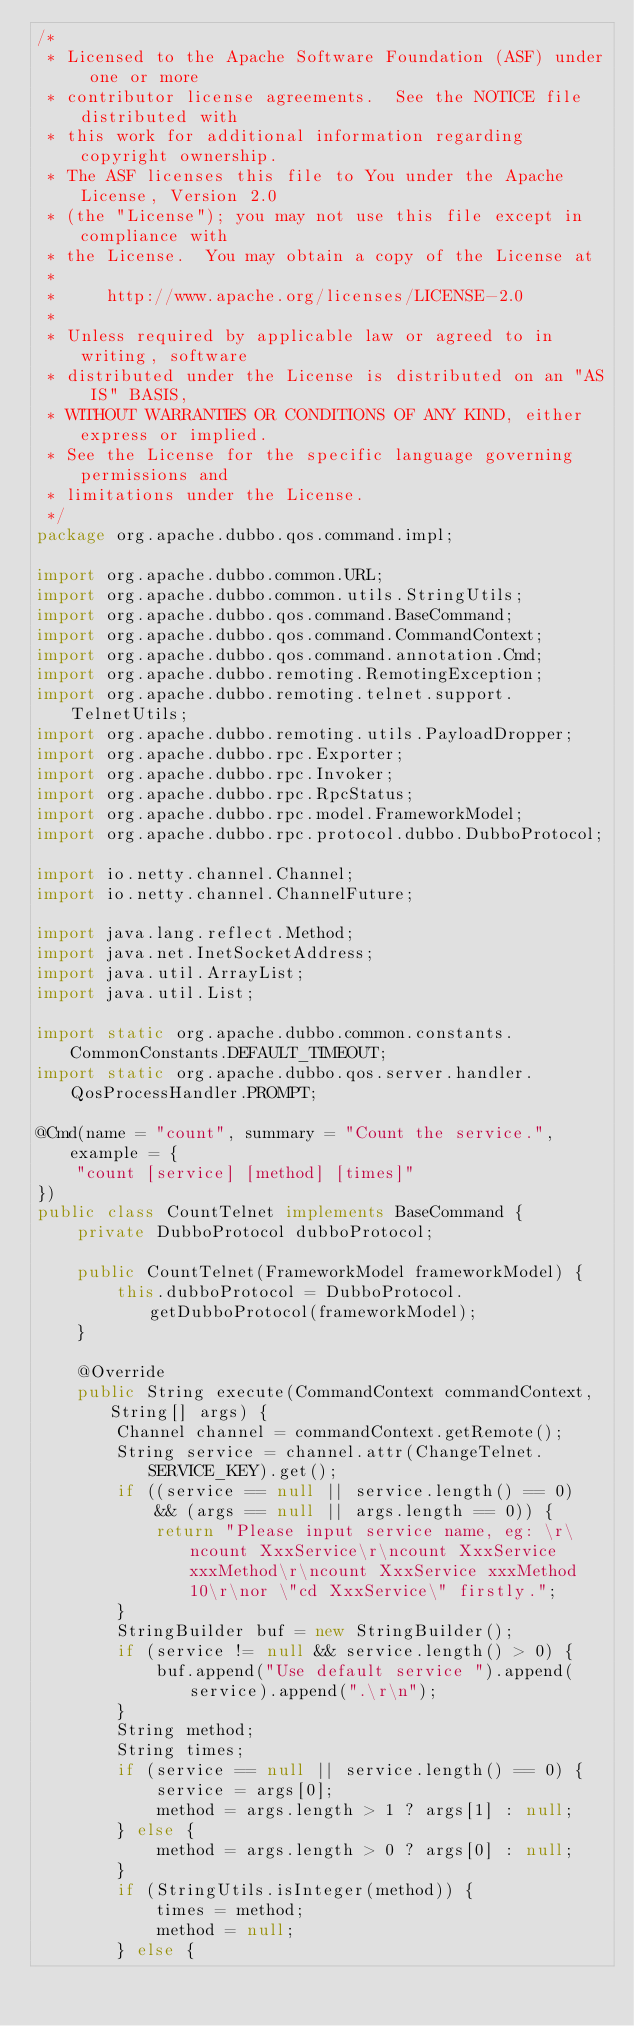Convert code to text. <code><loc_0><loc_0><loc_500><loc_500><_Java_>/*
 * Licensed to the Apache Software Foundation (ASF) under one or more
 * contributor license agreements.  See the NOTICE file distributed with
 * this work for additional information regarding copyright ownership.
 * The ASF licenses this file to You under the Apache License, Version 2.0
 * (the "License"); you may not use this file except in compliance with
 * the License.  You may obtain a copy of the License at
 *
 *     http://www.apache.org/licenses/LICENSE-2.0
 *
 * Unless required by applicable law or agreed to in writing, software
 * distributed under the License is distributed on an "AS IS" BASIS,
 * WITHOUT WARRANTIES OR CONDITIONS OF ANY KIND, either express or implied.
 * See the License for the specific language governing permissions and
 * limitations under the License.
 */
package org.apache.dubbo.qos.command.impl;

import org.apache.dubbo.common.URL;
import org.apache.dubbo.common.utils.StringUtils;
import org.apache.dubbo.qos.command.BaseCommand;
import org.apache.dubbo.qos.command.CommandContext;
import org.apache.dubbo.qos.command.annotation.Cmd;
import org.apache.dubbo.remoting.RemotingException;
import org.apache.dubbo.remoting.telnet.support.TelnetUtils;
import org.apache.dubbo.remoting.utils.PayloadDropper;
import org.apache.dubbo.rpc.Exporter;
import org.apache.dubbo.rpc.Invoker;
import org.apache.dubbo.rpc.RpcStatus;
import org.apache.dubbo.rpc.model.FrameworkModel;
import org.apache.dubbo.rpc.protocol.dubbo.DubboProtocol;

import io.netty.channel.Channel;
import io.netty.channel.ChannelFuture;

import java.lang.reflect.Method;
import java.net.InetSocketAddress;
import java.util.ArrayList;
import java.util.List;

import static org.apache.dubbo.common.constants.CommonConstants.DEFAULT_TIMEOUT;
import static org.apache.dubbo.qos.server.handler.QosProcessHandler.PROMPT;

@Cmd(name = "count", summary = "Count the service.", example = {
    "count [service] [method] [times]"
})
public class CountTelnet implements BaseCommand {
    private DubboProtocol dubboProtocol;

    public CountTelnet(FrameworkModel frameworkModel) {
        this.dubboProtocol = DubboProtocol.getDubboProtocol(frameworkModel);
    }

    @Override
    public String execute(CommandContext commandContext, String[] args) {
        Channel channel = commandContext.getRemote();
        String service = channel.attr(ChangeTelnet.SERVICE_KEY).get();
        if ((service == null || service.length() == 0)
            && (args == null || args.length == 0)) {
            return "Please input service name, eg: \r\ncount XxxService\r\ncount XxxService xxxMethod\r\ncount XxxService xxxMethod 10\r\nor \"cd XxxService\" firstly.";
        }
        StringBuilder buf = new StringBuilder();
        if (service != null && service.length() > 0) {
            buf.append("Use default service ").append(service).append(".\r\n");
        }
        String method;
        String times;
        if (service == null || service.length() == 0) {
            service = args[0];
            method = args.length > 1 ? args[1] : null;
        } else {
            method = args.length > 0 ? args[0] : null;
        }
        if (StringUtils.isInteger(method)) {
            times = method;
            method = null;
        } else {</code> 